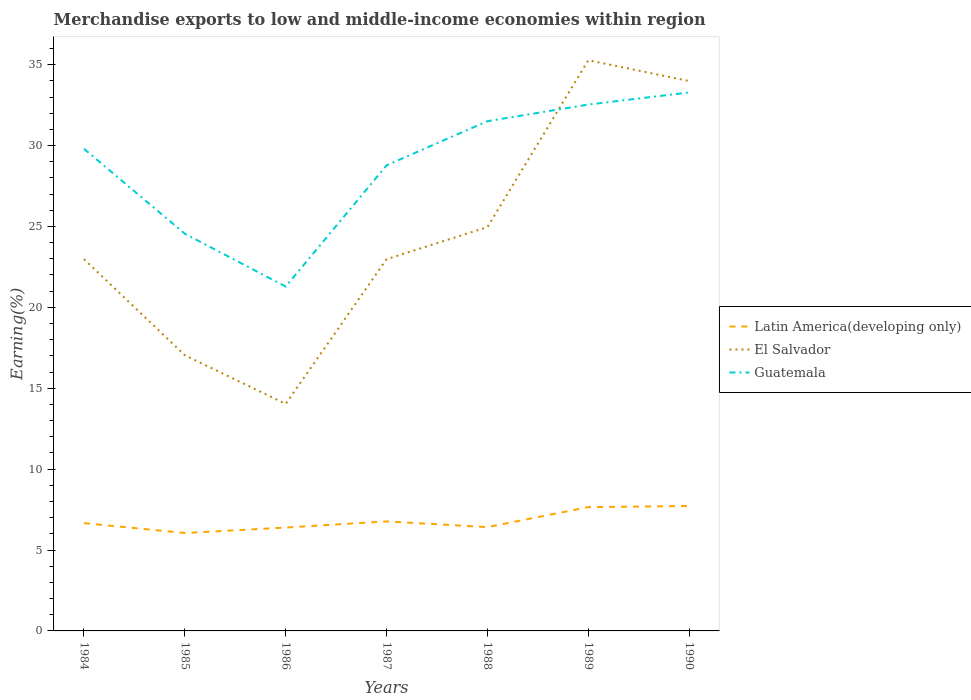How many different coloured lines are there?
Your answer should be compact. 3. Does the line corresponding to Guatemala intersect with the line corresponding to Latin America(developing only)?
Provide a short and direct response. No. Is the number of lines equal to the number of legend labels?
Offer a very short reply. Yes. Across all years, what is the maximum percentage of amount earned from merchandise exports in Guatemala?
Provide a short and direct response. 21.28. What is the total percentage of amount earned from merchandise exports in El Salvador in the graph?
Ensure brevity in your answer.  -5.94. What is the difference between the highest and the second highest percentage of amount earned from merchandise exports in El Salvador?
Give a very brief answer. 21.24. What is the difference between the highest and the lowest percentage of amount earned from merchandise exports in Latin America(developing only)?
Your response must be concise. 2. How many years are there in the graph?
Give a very brief answer. 7. How are the legend labels stacked?
Your response must be concise. Vertical. What is the title of the graph?
Offer a terse response. Merchandise exports to low and middle-income economies within region. Does "Central Europe" appear as one of the legend labels in the graph?
Offer a terse response. No. What is the label or title of the Y-axis?
Provide a succinct answer. Earning(%). What is the Earning(%) in Latin America(developing only) in 1984?
Offer a very short reply. 6.66. What is the Earning(%) of El Salvador in 1984?
Provide a short and direct response. 22.98. What is the Earning(%) in Guatemala in 1984?
Give a very brief answer. 29.8. What is the Earning(%) of Latin America(developing only) in 1985?
Keep it short and to the point. 6.05. What is the Earning(%) of El Salvador in 1985?
Give a very brief answer. 17.04. What is the Earning(%) of Guatemala in 1985?
Ensure brevity in your answer.  24.55. What is the Earning(%) in Latin America(developing only) in 1986?
Give a very brief answer. 6.39. What is the Earning(%) of El Salvador in 1986?
Offer a terse response. 14.03. What is the Earning(%) of Guatemala in 1986?
Offer a terse response. 21.28. What is the Earning(%) of Latin America(developing only) in 1987?
Offer a terse response. 6.77. What is the Earning(%) in El Salvador in 1987?
Provide a short and direct response. 22.98. What is the Earning(%) in Guatemala in 1987?
Provide a succinct answer. 28.78. What is the Earning(%) in Latin America(developing only) in 1988?
Give a very brief answer. 6.42. What is the Earning(%) in El Salvador in 1988?
Offer a terse response. 24.96. What is the Earning(%) in Guatemala in 1988?
Make the answer very short. 31.51. What is the Earning(%) of Latin America(developing only) in 1989?
Keep it short and to the point. 7.65. What is the Earning(%) of El Salvador in 1989?
Your response must be concise. 35.28. What is the Earning(%) in Guatemala in 1989?
Give a very brief answer. 32.53. What is the Earning(%) of Latin America(developing only) in 1990?
Offer a terse response. 7.72. What is the Earning(%) of El Salvador in 1990?
Keep it short and to the point. 33.99. What is the Earning(%) of Guatemala in 1990?
Ensure brevity in your answer.  33.28. Across all years, what is the maximum Earning(%) of Latin America(developing only)?
Offer a terse response. 7.72. Across all years, what is the maximum Earning(%) of El Salvador?
Provide a succinct answer. 35.28. Across all years, what is the maximum Earning(%) of Guatemala?
Offer a terse response. 33.28. Across all years, what is the minimum Earning(%) in Latin America(developing only)?
Your answer should be compact. 6.05. Across all years, what is the minimum Earning(%) of El Salvador?
Your answer should be compact. 14.03. Across all years, what is the minimum Earning(%) in Guatemala?
Offer a very short reply. 21.28. What is the total Earning(%) in Latin America(developing only) in the graph?
Ensure brevity in your answer.  47.66. What is the total Earning(%) of El Salvador in the graph?
Ensure brevity in your answer.  171.26. What is the total Earning(%) of Guatemala in the graph?
Ensure brevity in your answer.  201.74. What is the difference between the Earning(%) of Latin America(developing only) in 1984 and that in 1985?
Your answer should be compact. 0.61. What is the difference between the Earning(%) in El Salvador in 1984 and that in 1985?
Your response must be concise. 5.94. What is the difference between the Earning(%) in Guatemala in 1984 and that in 1985?
Give a very brief answer. 5.25. What is the difference between the Earning(%) of Latin America(developing only) in 1984 and that in 1986?
Offer a very short reply. 0.27. What is the difference between the Earning(%) in El Salvador in 1984 and that in 1986?
Your answer should be very brief. 8.95. What is the difference between the Earning(%) in Guatemala in 1984 and that in 1986?
Your answer should be very brief. 8.52. What is the difference between the Earning(%) of Latin America(developing only) in 1984 and that in 1987?
Ensure brevity in your answer.  -0.11. What is the difference between the Earning(%) of El Salvador in 1984 and that in 1987?
Keep it short and to the point. 0. What is the difference between the Earning(%) of Guatemala in 1984 and that in 1987?
Your answer should be compact. 1.02. What is the difference between the Earning(%) of Latin America(developing only) in 1984 and that in 1988?
Provide a succinct answer. 0.25. What is the difference between the Earning(%) of El Salvador in 1984 and that in 1988?
Provide a short and direct response. -1.98. What is the difference between the Earning(%) of Guatemala in 1984 and that in 1988?
Provide a succinct answer. -1.71. What is the difference between the Earning(%) in Latin America(developing only) in 1984 and that in 1989?
Keep it short and to the point. -0.99. What is the difference between the Earning(%) in El Salvador in 1984 and that in 1989?
Provide a short and direct response. -12.29. What is the difference between the Earning(%) in Guatemala in 1984 and that in 1989?
Offer a terse response. -2.74. What is the difference between the Earning(%) of Latin America(developing only) in 1984 and that in 1990?
Your answer should be very brief. -1.06. What is the difference between the Earning(%) in El Salvador in 1984 and that in 1990?
Your answer should be compact. -11.01. What is the difference between the Earning(%) in Guatemala in 1984 and that in 1990?
Ensure brevity in your answer.  -3.48. What is the difference between the Earning(%) of Latin America(developing only) in 1985 and that in 1986?
Keep it short and to the point. -0.34. What is the difference between the Earning(%) of El Salvador in 1985 and that in 1986?
Ensure brevity in your answer.  3.01. What is the difference between the Earning(%) in Guatemala in 1985 and that in 1986?
Your response must be concise. 3.27. What is the difference between the Earning(%) in Latin America(developing only) in 1985 and that in 1987?
Keep it short and to the point. -0.72. What is the difference between the Earning(%) of El Salvador in 1985 and that in 1987?
Your response must be concise. -5.94. What is the difference between the Earning(%) in Guatemala in 1985 and that in 1987?
Your response must be concise. -4.23. What is the difference between the Earning(%) in Latin America(developing only) in 1985 and that in 1988?
Keep it short and to the point. -0.37. What is the difference between the Earning(%) in El Salvador in 1985 and that in 1988?
Your response must be concise. -7.92. What is the difference between the Earning(%) in Guatemala in 1985 and that in 1988?
Provide a short and direct response. -6.96. What is the difference between the Earning(%) of Latin America(developing only) in 1985 and that in 1989?
Ensure brevity in your answer.  -1.6. What is the difference between the Earning(%) of El Salvador in 1985 and that in 1989?
Provide a succinct answer. -18.24. What is the difference between the Earning(%) of Guatemala in 1985 and that in 1989?
Your answer should be compact. -7.98. What is the difference between the Earning(%) of Latin America(developing only) in 1985 and that in 1990?
Your answer should be compact. -1.67. What is the difference between the Earning(%) of El Salvador in 1985 and that in 1990?
Offer a terse response. -16.95. What is the difference between the Earning(%) of Guatemala in 1985 and that in 1990?
Offer a terse response. -8.73. What is the difference between the Earning(%) of Latin America(developing only) in 1986 and that in 1987?
Offer a terse response. -0.38. What is the difference between the Earning(%) of El Salvador in 1986 and that in 1987?
Your answer should be compact. -8.95. What is the difference between the Earning(%) in Guatemala in 1986 and that in 1987?
Make the answer very short. -7.49. What is the difference between the Earning(%) in Latin America(developing only) in 1986 and that in 1988?
Provide a succinct answer. -0.03. What is the difference between the Earning(%) of El Salvador in 1986 and that in 1988?
Your answer should be very brief. -10.93. What is the difference between the Earning(%) in Guatemala in 1986 and that in 1988?
Give a very brief answer. -10.22. What is the difference between the Earning(%) in Latin America(developing only) in 1986 and that in 1989?
Provide a succinct answer. -1.26. What is the difference between the Earning(%) of El Salvador in 1986 and that in 1989?
Offer a very short reply. -21.24. What is the difference between the Earning(%) of Guatemala in 1986 and that in 1989?
Ensure brevity in your answer.  -11.25. What is the difference between the Earning(%) in Latin America(developing only) in 1986 and that in 1990?
Ensure brevity in your answer.  -1.33. What is the difference between the Earning(%) of El Salvador in 1986 and that in 1990?
Make the answer very short. -19.96. What is the difference between the Earning(%) in Guatemala in 1986 and that in 1990?
Offer a terse response. -12. What is the difference between the Earning(%) of Latin America(developing only) in 1987 and that in 1988?
Offer a very short reply. 0.35. What is the difference between the Earning(%) in El Salvador in 1987 and that in 1988?
Make the answer very short. -1.98. What is the difference between the Earning(%) of Guatemala in 1987 and that in 1988?
Keep it short and to the point. -2.73. What is the difference between the Earning(%) of Latin America(developing only) in 1987 and that in 1989?
Make the answer very short. -0.88. What is the difference between the Earning(%) of El Salvador in 1987 and that in 1989?
Ensure brevity in your answer.  -12.3. What is the difference between the Earning(%) in Guatemala in 1987 and that in 1989?
Keep it short and to the point. -3.76. What is the difference between the Earning(%) of Latin America(developing only) in 1987 and that in 1990?
Your answer should be very brief. -0.95. What is the difference between the Earning(%) of El Salvador in 1987 and that in 1990?
Your answer should be very brief. -11.01. What is the difference between the Earning(%) in Guatemala in 1987 and that in 1990?
Your response must be concise. -4.51. What is the difference between the Earning(%) of Latin America(developing only) in 1988 and that in 1989?
Your answer should be compact. -1.24. What is the difference between the Earning(%) in El Salvador in 1988 and that in 1989?
Provide a short and direct response. -10.31. What is the difference between the Earning(%) of Guatemala in 1988 and that in 1989?
Keep it short and to the point. -1.03. What is the difference between the Earning(%) in Latin America(developing only) in 1988 and that in 1990?
Keep it short and to the point. -1.3. What is the difference between the Earning(%) of El Salvador in 1988 and that in 1990?
Keep it short and to the point. -9.03. What is the difference between the Earning(%) of Guatemala in 1988 and that in 1990?
Make the answer very short. -1.78. What is the difference between the Earning(%) in Latin America(developing only) in 1989 and that in 1990?
Keep it short and to the point. -0.07. What is the difference between the Earning(%) in El Salvador in 1989 and that in 1990?
Give a very brief answer. 1.29. What is the difference between the Earning(%) in Guatemala in 1989 and that in 1990?
Your response must be concise. -0.75. What is the difference between the Earning(%) of Latin America(developing only) in 1984 and the Earning(%) of El Salvador in 1985?
Provide a short and direct response. -10.38. What is the difference between the Earning(%) in Latin America(developing only) in 1984 and the Earning(%) in Guatemala in 1985?
Make the answer very short. -17.89. What is the difference between the Earning(%) in El Salvador in 1984 and the Earning(%) in Guatemala in 1985?
Your response must be concise. -1.57. What is the difference between the Earning(%) of Latin America(developing only) in 1984 and the Earning(%) of El Salvador in 1986?
Your response must be concise. -7.37. What is the difference between the Earning(%) of Latin America(developing only) in 1984 and the Earning(%) of Guatemala in 1986?
Your response must be concise. -14.62. What is the difference between the Earning(%) of El Salvador in 1984 and the Earning(%) of Guatemala in 1986?
Your answer should be compact. 1.7. What is the difference between the Earning(%) of Latin America(developing only) in 1984 and the Earning(%) of El Salvador in 1987?
Your answer should be compact. -16.32. What is the difference between the Earning(%) in Latin America(developing only) in 1984 and the Earning(%) in Guatemala in 1987?
Provide a short and direct response. -22.12. What is the difference between the Earning(%) of El Salvador in 1984 and the Earning(%) of Guatemala in 1987?
Provide a short and direct response. -5.8. What is the difference between the Earning(%) of Latin America(developing only) in 1984 and the Earning(%) of El Salvador in 1988?
Your response must be concise. -18.3. What is the difference between the Earning(%) of Latin America(developing only) in 1984 and the Earning(%) of Guatemala in 1988?
Your answer should be compact. -24.85. What is the difference between the Earning(%) of El Salvador in 1984 and the Earning(%) of Guatemala in 1988?
Offer a terse response. -8.53. What is the difference between the Earning(%) in Latin America(developing only) in 1984 and the Earning(%) in El Salvador in 1989?
Provide a succinct answer. -28.61. What is the difference between the Earning(%) of Latin America(developing only) in 1984 and the Earning(%) of Guatemala in 1989?
Offer a very short reply. -25.87. What is the difference between the Earning(%) of El Salvador in 1984 and the Earning(%) of Guatemala in 1989?
Your answer should be compact. -9.55. What is the difference between the Earning(%) of Latin America(developing only) in 1984 and the Earning(%) of El Salvador in 1990?
Offer a very short reply. -27.33. What is the difference between the Earning(%) of Latin America(developing only) in 1984 and the Earning(%) of Guatemala in 1990?
Your response must be concise. -26.62. What is the difference between the Earning(%) of El Salvador in 1984 and the Earning(%) of Guatemala in 1990?
Ensure brevity in your answer.  -10.3. What is the difference between the Earning(%) in Latin America(developing only) in 1985 and the Earning(%) in El Salvador in 1986?
Your answer should be very brief. -7.98. What is the difference between the Earning(%) of Latin America(developing only) in 1985 and the Earning(%) of Guatemala in 1986?
Give a very brief answer. -15.23. What is the difference between the Earning(%) in El Salvador in 1985 and the Earning(%) in Guatemala in 1986?
Your response must be concise. -4.25. What is the difference between the Earning(%) in Latin America(developing only) in 1985 and the Earning(%) in El Salvador in 1987?
Make the answer very short. -16.93. What is the difference between the Earning(%) of Latin America(developing only) in 1985 and the Earning(%) of Guatemala in 1987?
Provide a succinct answer. -22.73. What is the difference between the Earning(%) in El Salvador in 1985 and the Earning(%) in Guatemala in 1987?
Your answer should be very brief. -11.74. What is the difference between the Earning(%) of Latin America(developing only) in 1985 and the Earning(%) of El Salvador in 1988?
Make the answer very short. -18.91. What is the difference between the Earning(%) of Latin America(developing only) in 1985 and the Earning(%) of Guatemala in 1988?
Make the answer very short. -25.46. What is the difference between the Earning(%) of El Salvador in 1985 and the Earning(%) of Guatemala in 1988?
Make the answer very short. -14.47. What is the difference between the Earning(%) of Latin America(developing only) in 1985 and the Earning(%) of El Salvador in 1989?
Give a very brief answer. -29.22. What is the difference between the Earning(%) of Latin America(developing only) in 1985 and the Earning(%) of Guatemala in 1989?
Provide a succinct answer. -26.48. What is the difference between the Earning(%) of El Salvador in 1985 and the Earning(%) of Guatemala in 1989?
Offer a very short reply. -15.5. What is the difference between the Earning(%) in Latin America(developing only) in 1985 and the Earning(%) in El Salvador in 1990?
Give a very brief answer. -27.94. What is the difference between the Earning(%) of Latin America(developing only) in 1985 and the Earning(%) of Guatemala in 1990?
Your answer should be compact. -27.23. What is the difference between the Earning(%) of El Salvador in 1985 and the Earning(%) of Guatemala in 1990?
Your answer should be very brief. -16.25. What is the difference between the Earning(%) of Latin America(developing only) in 1986 and the Earning(%) of El Salvador in 1987?
Your response must be concise. -16.59. What is the difference between the Earning(%) in Latin America(developing only) in 1986 and the Earning(%) in Guatemala in 1987?
Your response must be concise. -22.39. What is the difference between the Earning(%) of El Salvador in 1986 and the Earning(%) of Guatemala in 1987?
Provide a succinct answer. -14.75. What is the difference between the Earning(%) in Latin America(developing only) in 1986 and the Earning(%) in El Salvador in 1988?
Your response must be concise. -18.57. What is the difference between the Earning(%) of Latin America(developing only) in 1986 and the Earning(%) of Guatemala in 1988?
Provide a short and direct response. -25.12. What is the difference between the Earning(%) of El Salvador in 1986 and the Earning(%) of Guatemala in 1988?
Keep it short and to the point. -17.48. What is the difference between the Earning(%) in Latin America(developing only) in 1986 and the Earning(%) in El Salvador in 1989?
Ensure brevity in your answer.  -28.89. What is the difference between the Earning(%) in Latin America(developing only) in 1986 and the Earning(%) in Guatemala in 1989?
Keep it short and to the point. -26.15. What is the difference between the Earning(%) of El Salvador in 1986 and the Earning(%) of Guatemala in 1989?
Make the answer very short. -18.5. What is the difference between the Earning(%) of Latin America(developing only) in 1986 and the Earning(%) of El Salvador in 1990?
Provide a short and direct response. -27.6. What is the difference between the Earning(%) of Latin America(developing only) in 1986 and the Earning(%) of Guatemala in 1990?
Offer a terse response. -26.89. What is the difference between the Earning(%) in El Salvador in 1986 and the Earning(%) in Guatemala in 1990?
Make the answer very short. -19.25. What is the difference between the Earning(%) of Latin America(developing only) in 1987 and the Earning(%) of El Salvador in 1988?
Give a very brief answer. -18.19. What is the difference between the Earning(%) of Latin America(developing only) in 1987 and the Earning(%) of Guatemala in 1988?
Keep it short and to the point. -24.74. What is the difference between the Earning(%) in El Salvador in 1987 and the Earning(%) in Guatemala in 1988?
Make the answer very short. -8.53. What is the difference between the Earning(%) of Latin America(developing only) in 1987 and the Earning(%) of El Salvador in 1989?
Make the answer very short. -28.51. What is the difference between the Earning(%) of Latin America(developing only) in 1987 and the Earning(%) of Guatemala in 1989?
Keep it short and to the point. -25.77. What is the difference between the Earning(%) in El Salvador in 1987 and the Earning(%) in Guatemala in 1989?
Your response must be concise. -9.56. What is the difference between the Earning(%) in Latin America(developing only) in 1987 and the Earning(%) in El Salvador in 1990?
Provide a short and direct response. -27.22. What is the difference between the Earning(%) of Latin America(developing only) in 1987 and the Earning(%) of Guatemala in 1990?
Offer a very short reply. -26.52. What is the difference between the Earning(%) in El Salvador in 1987 and the Earning(%) in Guatemala in 1990?
Ensure brevity in your answer.  -10.31. What is the difference between the Earning(%) in Latin America(developing only) in 1988 and the Earning(%) in El Salvador in 1989?
Your answer should be very brief. -28.86. What is the difference between the Earning(%) of Latin America(developing only) in 1988 and the Earning(%) of Guatemala in 1989?
Keep it short and to the point. -26.12. What is the difference between the Earning(%) of El Salvador in 1988 and the Earning(%) of Guatemala in 1989?
Keep it short and to the point. -7.57. What is the difference between the Earning(%) in Latin America(developing only) in 1988 and the Earning(%) in El Salvador in 1990?
Ensure brevity in your answer.  -27.57. What is the difference between the Earning(%) of Latin America(developing only) in 1988 and the Earning(%) of Guatemala in 1990?
Make the answer very short. -26.87. What is the difference between the Earning(%) in El Salvador in 1988 and the Earning(%) in Guatemala in 1990?
Give a very brief answer. -8.32. What is the difference between the Earning(%) of Latin America(developing only) in 1989 and the Earning(%) of El Salvador in 1990?
Give a very brief answer. -26.34. What is the difference between the Earning(%) in Latin America(developing only) in 1989 and the Earning(%) in Guatemala in 1990?
Offer a terse response. -25.63. What is the difference between the Earning(%) in El Salvador in 1989 and the Earning(%) in Guatemala in 1990?
Keep it short and to the point. 1.99. What is the average Earning(%) of Latin America(developing only) per year?
Offer a very short reply. 6.81. What is the average Earning(%) in El Salvador per year?
Offer a terse response. 24.47. What is the average Earning(%) of Guatemala per year?
Your response must be concise. 28.82. In the year 1984, what is the difference between the Earning(%) in Latin America(developing only) and Earning(%) in El Salvador?
Keep it short and to the point. -16.32. In the year 1984, what is the difference between the Earning(%) of Latin America(developing only) and Earning(%) of Guatemala?
Your response must be concise. -23.14. In the year 1984, what is the difference between the Earning(%) of El Salvador and Earning(%) of Guatemala?
Ensure brevity in your answer.  -6.82. In the year 1985, what is the difference between the Earning(%) in Latin America(developing only) and Earning(%) in El Salvador?
Keep it short and to the point. -10.99. In the year 1985, what is the difference between the Earning(%) of Latin America(developing only) and Earning(%) of Guatemala?
Keep it short and to the point. -18.5. In the year 1985, what is the difference between the Earning(%) in El Salvador and Earning(%) in Guatemala?
Your response must be concise. -7.51. In the year 1986, what is the difference between the Earning(%) of Latin America(developing only) and Earning(%) of El Salvador?
Offer a very short reply. -7.64. In the year 1986, what is the difference between the Earning(%) in Latin America(developing only) and Earning(%) in Guatemala?
Offer a terse response. -14.89. In the year 1986, what is the difference between the Earning(%) in El Salvador and Earning(%) in Guatemala?
Offer a very short reply. -7.25. In the year 1987, what is the difference between the Earning(%) in Latin America(developing only) and Earning(%) in El Salvador?
Provide a short and direct response. -16.21. In the year 1987, what is the difference between the Earning(%) of Latin America(developing only) and Earning(%) of Guatemala?
Your answer should be very brief. -22.01. In the year 1987, what is the difference between the Earning(%) of El Salvador and Earning(%) of Guatemala?
Provide a succinct answer. -5.8. In the year 1988, what is the difference between the Earning(%) in Latin America(developing only) and Earning(%) in El Salvador?
Make the answer very short. -18.54. In the year 1988, what is the difference between the Earning(%) of Latin America(developing only) and Earning(%) of Guatemala?
Keep it short and to the point. -25.09. In the year 1988, what is the difference between the Earning(%) in El Salvador and Earning(%) in Guatemala?
Your answer should be very brief. -6.55. In the year 1989, what is the difference between the Earning(%) in Latin America(developing only) and Earning(%) in El Salvador?
Your answer should be compact. -27.62. In the year 1989, what is the difference between the Earning(%) of Latin America(developing only) and Earning(%) of Guatemala?
Offer a terse response. -24.88. In the year 1989, what is the difference between the Earning(%) of El Salvador and Earning(%) of Guatemala?
Your response must be concise. 2.74. In the year 1990, what is the difference between the Earning(%) of Latin America(developing only) and Earning(%) of El Salvador?
Keep it short and to the point. -26.27. In the year 1990, what is the difference between the Earning(%) of Latin America(developing only) and Earning(%) of Guatemala?
Ensure brevity in your answer.  -25.57. In the year 1990, what is the difference between the Earning(%) of El Salvador and Earning(%) of Guatemala?
Your answer should be very brief. 0.7. What is the ratio of the Earning(%) in Latin America(developing only) in 1984 to that in 1985?
Provide a short and direct response. 1.1. What is the ratio of the Earning(%) of El Salvador in 1984 to that in 1985?
Offer a terse response. 1.35. What is the ratio of the Earning(%) of Guatemala in 1984 to that in 1985?
Provide a short and direct response. 1.21. What is the ratio of the Earning(%) of Latin America(developing only) in 1984 to that in 1986?
Make the answer very short. 1.04. What is the ratio of the Earning(%) in El Salvador in 1984 to that in 1986?
Give a very brief answer. 1.64. What is the ratio of the Earning(%) of Guatemala in 1984 to that in 1986?
Make the answer very short. 1.4. What is the ratio of the Earning(%) of Latin America(developing only) in 1984 to that in 1987?
Offer a very short reply. 0.98. What is the ratio of the Earning(%) of Guatemala in 1984 to that in 1987?
Your answer should be very brief. 1.04. What is the ratio of the Earning(%) in Latin America(developing only) in 1984 to that in 1988?
Ensure brevity in your answer.  1.04. What is the ratio of the Earning(%) of El Salvador in 1984 to that in 1988?
Keep it short and to the point. 0.92. What is the ratio of the Earning(%) of Guatemala in 1984 to that in 1988?
Give a very brief answer. 0.95. What is the ratio of the Earning(%) in Latin America(developing only) in 1984 to that in 1989?
Offer a very short reply. 0.87. What is the ratio of the Earning(%) of El Salvador in 1984 to that in 1989?
Ensure brevity in your answer.  0.65. What is the ratio of the Earning(%) of Guatemala in 1984 to that in 1989?
Provide a succinct answer. 0.92. What is the ratio of the Earning(%) in Latin America(developing only) in 1984 to that in 1990?
Your answer should be very brief. 0.86. What is the ratio of the Earning(%) of El Salvador in 1984 to that in 1990?
Give a very brief answer. 0.68. What is the ratio of the Earning(%) of Guatemala in 1984 to that in 1990?
Ensure brevity in your answer.  0.9. What is the ratio of the Earning(%) of Latin America(developing only) in 1985 to that in 1986?
Your answer should be compact. 0.95. What is the ratio of the Earning(%) of El Salvador in 1985 to that in 1986?
Offer a very short reply. 1.21. What is the ratio of the Earning(%) in Guatemala in 1985 to that in 1986?
Your answer should be compact. 1.15. What is the ratio of the Earning(%) of Latin America(developing only) in 1985 to that in 1987?
Offer a very short reply. 0.89. What is the ratio of the Earning(%) in El Salvador in 1985 to that in 1987?
Your answer should be compact. 0.74. What is the ratio of the Earning(%) in Guatemala in 1985 to that in 1987?
Provide a short and direct response. 0.85. What is the ratio of the Earning(%) of Latin America(developing only) in 1985 to that in 1988?
Keep it short and to the point. 0.94. What is the ratio of the Earning(%) of El Salvador in 1985 to that in 1988?
Your answer should be compact. 0.68. What is the ratio of the Earning(%) of Guatemala in 1985 to that in 1988?
Offer a terse response. 0.78. What is the ratio of the Earning(%) of Latin America(developing only) in 1985 to that in 1989?
Provide a succinct answer. 0.79. What is the ratio of the Earning(%) in El Salvador in 1985 to that in 1989?
Provide a short and direct response. 0.48. What is the ratio of the Earning(%) in Guatemala in 1985 to that in 1989?
Provide a succinct answer. 0.75. What is the ratio of the Earning(%) of Latin America(developing only) in 1985 to that in 1990?
Ensure brevity in your answer.  0.78. What is the ratio of the Earning(%) of El Salvador in 1985 to that in 1990?
Offer a very short reply. 0.5. What is the ratio of the Earning(%) in Guatemala in 1985 to that in 1990?
Your answer should be very brief. 0.74. What is the ratio of the Earning(%) of Latin America(developing only) in 1986 to that in 1987?
Your answer should be compact. 0.94. What is the ratio of the Earning(%) of El Salvador in 1986 to that in 1987?
Your answer should be very brief. 0.61. What is the ratio of the Earning(%) in Guatemala in 1986 to that in 1987?
Make the answer very short. 0.74. What is the ratio of the Earning(%) in Latin America(developing only) in 1986 to that in 1988?
Offer a very short reply. 1. What is the ratio of the Earning(%) in El Salvador in 1986 to that in 1988?
Your answer should be compact. 0.56. What is the ratio of the Earning(%) in Guatemala in 1986 to that in 1988?
Your answer should be compact. 0.68. What is the ratio of the Earning(%) of Latin America(developing only) in 1986 to that in 1989?
Your response must be concise. 0.83. What is the ratio of the Earning(%) of El Salvador in 1986 to that in 1989?
Ensure brevity in your answer.  0.4. What is the ratio of the Earning(%) of Guatemala in 1986 to that in 1989?
Keep it short and to the point. 0.65. What is the ratio of the Earning(%) of Latin America(developing only) in 1986 to that in 1990?
Ensure brevity in your answer.  0.83. What is the ratio of the Earning(%) in El Salvador in 1986 to that in 1990?
Give a very brief answer. 0.41. What is the ratio of the Earning(%) of Guatemala in 1986 to that in 1990?
Give a very brief answer. 0.64. What is the ratio of the Earning(%) in Latin America(developing only) in 1987 to that in 1988?
Ensure brevity in your answer.  1.05. What is the ratio of the Earning(%) in El Salvador in 1987 to that in 1988?
Offer a very short reply. 0.92. What is the ratio of the Earning(%) in Guatemala in 1987 to that in 1988?
Your answer should be compact. 0.91. What is the ratio of the Earning(%) in Latin America(developing only) in 1987 to that in 1989?
Offer a very short reply. 0.88. What is the ratio of the Earning(%) in El Salvador in 1987 to that in 1989?
Offer a terse response. 0.65. What is the ratio of the Earning(%) in Guatemala in 1987 to that in 1989?
Make the answer very short. 0.88. What is the ratio of the Earning(%) of Latin America(developing only) in 1987 to that in 1990?
Provide a short and direct response. 0.88. What is the ratio of the Earning(%) of El Salvador in 1987 to that in 1990?
Offer a very short reply. 0.68. What is the ratio of the Earning(%) in Guatemala in 1987 to that in 1990?
Give a very brief answer. 0.86. What is the ratio of the Earning(%) in Latin America(developing only) in 1988 to that in 1989?
Provide a short and direct response. 0.84. What is the ratio of the Earning(%) in El Salvador in 1988 to that in 1989?
Give a very brief answer. 0.71. What is the ratio of the Earning(%) in Guatemala in 1988 to that in 1989?
Give a very brief answer. 0.97. What is the ratio of the Earning(%) in Latin America(developing only) in 1988 to that in 1990?
Ensure brevity in your answer.  0.83. What is the ratio of the Earning(%) in El Salvador in 1988 to that in 1990?
Keep it short and to the point. 0.73. What is the ratio of the Earning(%) in Guatemala in 1988 to that in 1990?
Provide a succinct answer. 0.95. What is the ratio of the Earning(%) of Latin America(developing only) in 1989 to that in 1990?
Provide a short and direct response. 0.99. What is the ratio of the Earning(%) of El Salvador in 1989 to that in 1990?
Your response must be concise. 1.04. What is the ratio of the Earning(%) in Guatemala in 1989 to that in 1990?
Offer a very short reply. 0.98. What is the difference between the highest and the second highest Earning(%) of Latin America(developing only)?
Keep it short and to the point. 0.07. What is the difference between the highest and the second highest Earning(%) of El Salvador?
Provide a short and direct response. 1.29. What is the difference between the highest and the second highest Earning(%) in Guatemala?
Your answer should be compact. 0.75. What is the difference between the highest and the lowest Earning(%) in Latin America(developing only)?
Offer a very short reply. 1.67. What is the difference between the highest and the lowest Earning(%) of El Salvador?
Offer a terse response. 21.24. What is the difference between the highest and the lowest Earning(%) in Guatemala?
Offer a terse response. 12. 